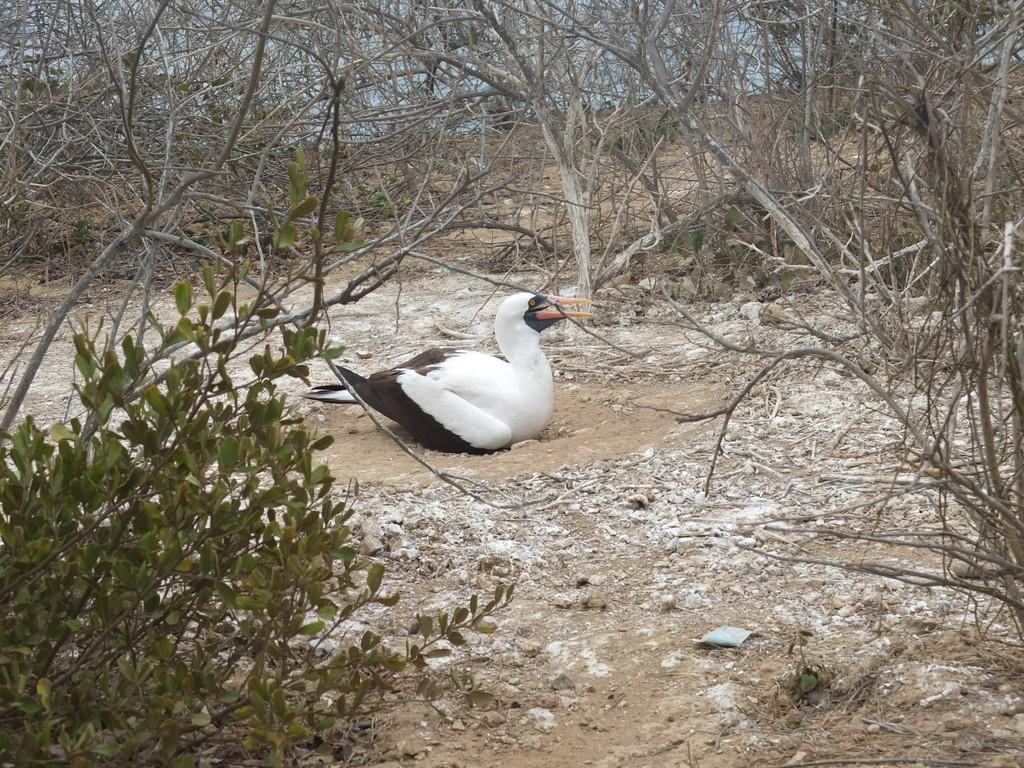What type of animal can be seen in the picture? There is a bird in the picture. Can you describe the bird's coloring? The bird is white and black in color. What type of natural environment is visible in the picture? There are trees visible in the picture. What other type of plant can be seen in the picture? There is a plant in the picture. What is the purpose of the rabbit in the picture? There is no rabbit present in the picture, so there is no purpose for a rabbit. 